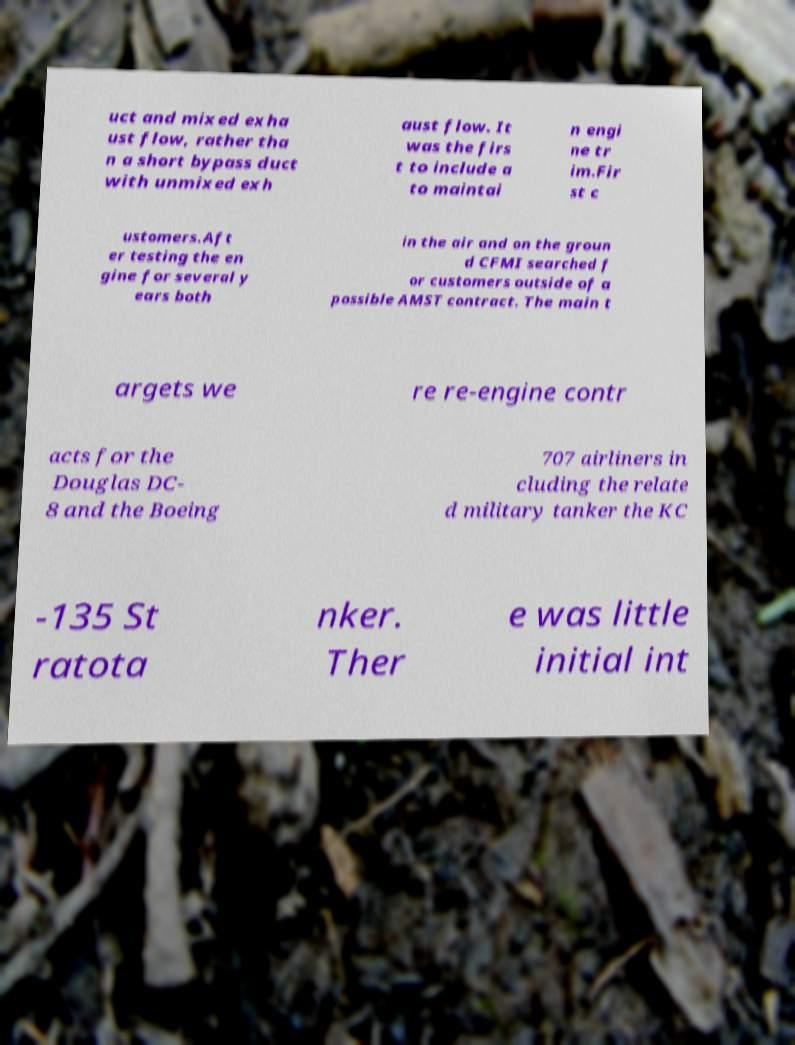For documentation purposes, I need the text within this image transcribed. Could you provide that? uct and mixed exha ust flow, rather tha n a short bypass duct with unmixed exh aust flow. It was the firs t to include a to maintai n engi ne tr im.Fir st c ustomers.Aft er testing the en gine for several y ears both in the air and on the groun d CFMI searched f or customers outside of a possible AMST contract. The main t argets we re re-engine contr acts for the Douglas DC- 8 and the Boeing 707 airliners in cluding the relate d military tanker the KC -135 St ratota nker. Ther e was little initial int 